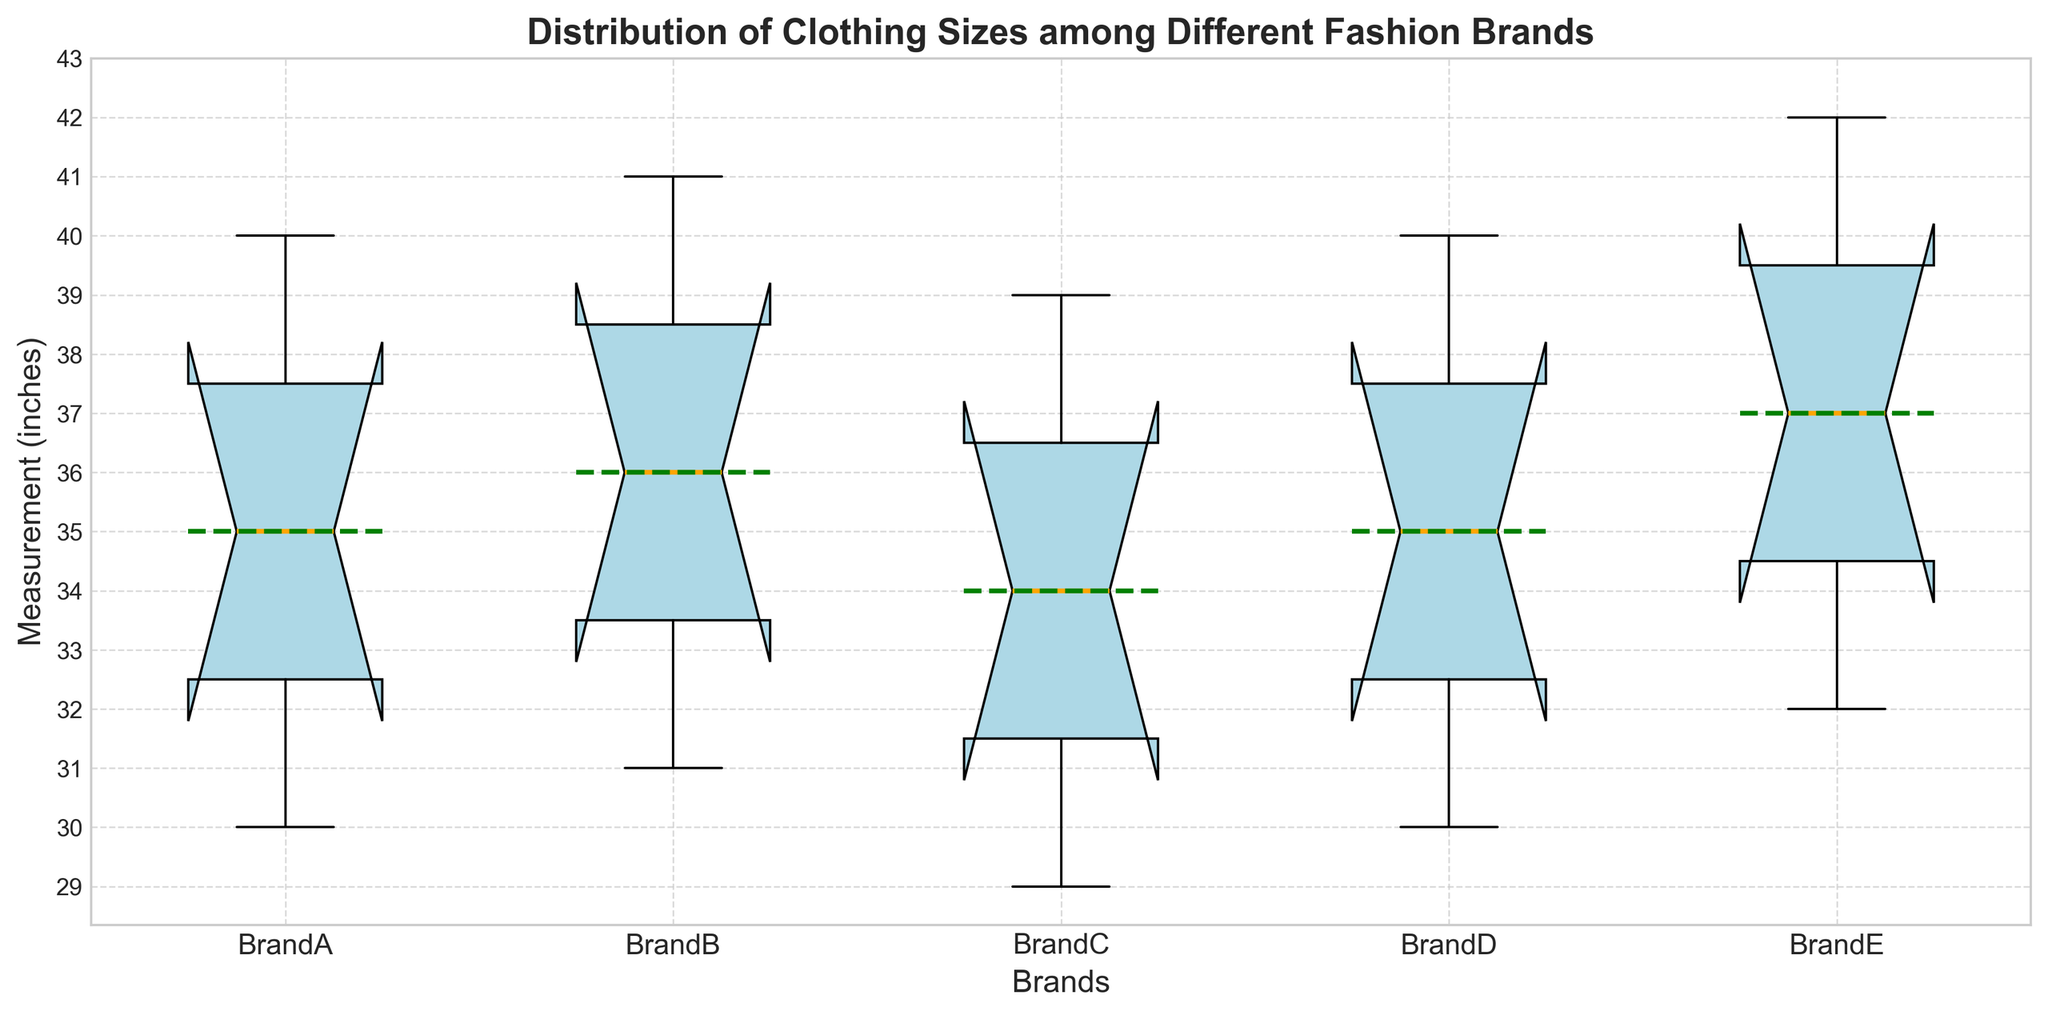Which brand has the smallest median measurement for clothing sizes? By looking at the box plot, the median measurement of each brand is marked by an orange line in the box. The brand with the smallest median measurement will have the lowest position for the orange line among all brands.
Answer: BrandC Which brand has the largest interquartile range (IQR)? The interquartile range (IQR) is the difference between the upper quartile (Q3) and lower quartile (Q1). By observing the height of the boxes, the brand with the tallest box will have the largest IQR.
Answer: BrandE Which brand has the highest mean measurement for clothing sizes? The mean value is indicated by a dotted green line across the boxes. The brand with the highest mean value will have the dotted green line positioned higher than others.
Answer: BrandE Comparing BrandA and BrandD, which one has a more consistent range of measurements? A more consistent range of measurements would have a smaller overall range (difference between the highest and lowest measurements, indicated by the whiskers). By comparing the whisker lengths of BrandA and BrandD, the brand with shorter whiskers has more consistent measurements.
Answer: BrandA Between BrandB and BrandC, which brand shows a greater variance in measurements? Variance includes the overall spread of the data. Box plots display this as the spread of the whiskers and the size of the box. The brand with the larger box and longer whiskers shows greater variance.
Answer: BrandB What is the median measurement of BrandE? The median measurement is indicated by the orange line within the box on the box plot. By checking the position of the orange line within BrandE's box, we can identify the median value.
Answer: 36 What is the range of measurements for BrandC? The range is determined by the difference between the maximum and minimum values (the endpoints of the whiskers). By identifying these points on BrandC's box plot, we can compute the range.
Answer: 10 Which brand displays the most outliers, and how are they visually represented? Outliers are typically depicted as individual points outside the whiskers. By counting the number of these points for each brand, we determine which brand has the most outliers.
Answer: No brand displays outliers Are the median measurements for all brands significantly different? By visually comparing the positions of the orange lines (medians) across all brands, we can assess if there are notable differences among them. Small vertical gaps between the orange lines mean less significant differences.
Answer: No significant differences Is the median measurement of BrandD equal to the median measurement of BrandA? To determine if medians are equal, compare the positions of the orange lines within their respective boxes. If they align horizontally at the same level, then the medians are equal.
Answer: Yes 